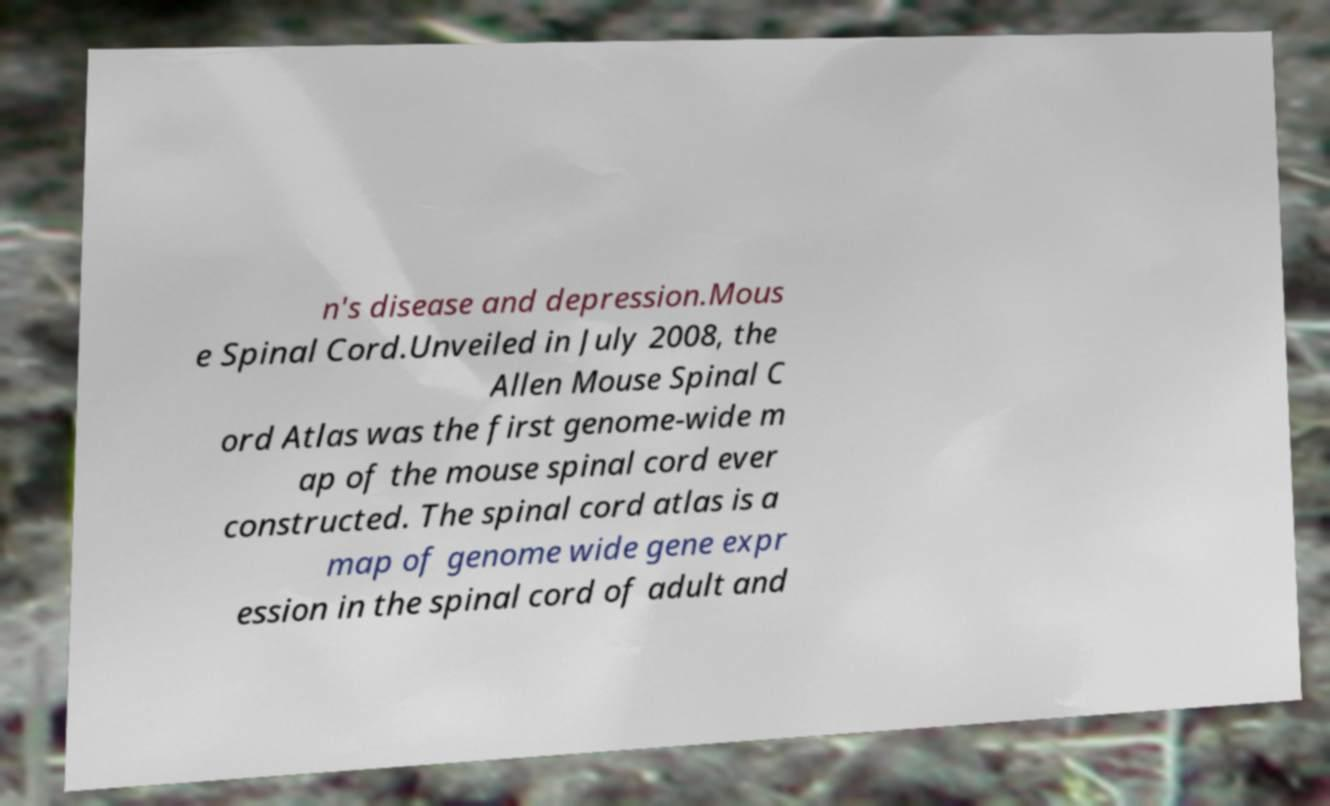Can you read and provide the text displayed in the image?This photo seems to have some interesting text. Can you extract and type it out for me? n's disease and depression.Mous e Spinal Cord.Unveiled in July 2008, the Allen Mouse Spinal C ord Atlas was the first genome-wide m ap of the mouse spinal cord ever constructed. The spinal cord atlas is a map of genome wide gene expr ession in the spinal cord of adult and 